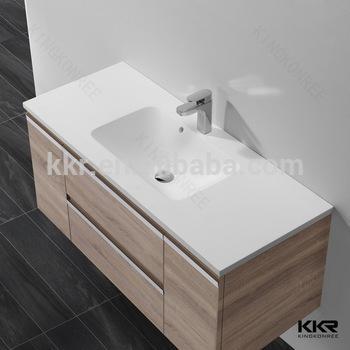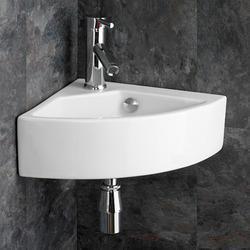The first image is the image on the left, the second image is the image on the right. Evaluate the accuracy of this statement regarding the images: "The sink in the right image has a black counter top.". Is it true? Answer yes or no. No. The first image is the image on the left, the second image is the image on the right. Evaluate the accuracy of this statement regarding the images: "One image shows a rectangular vanity with a shell-shaped sink carved into it, beneath a fauced mounted on the wall.". Is it true? Answer yes or no. No. 